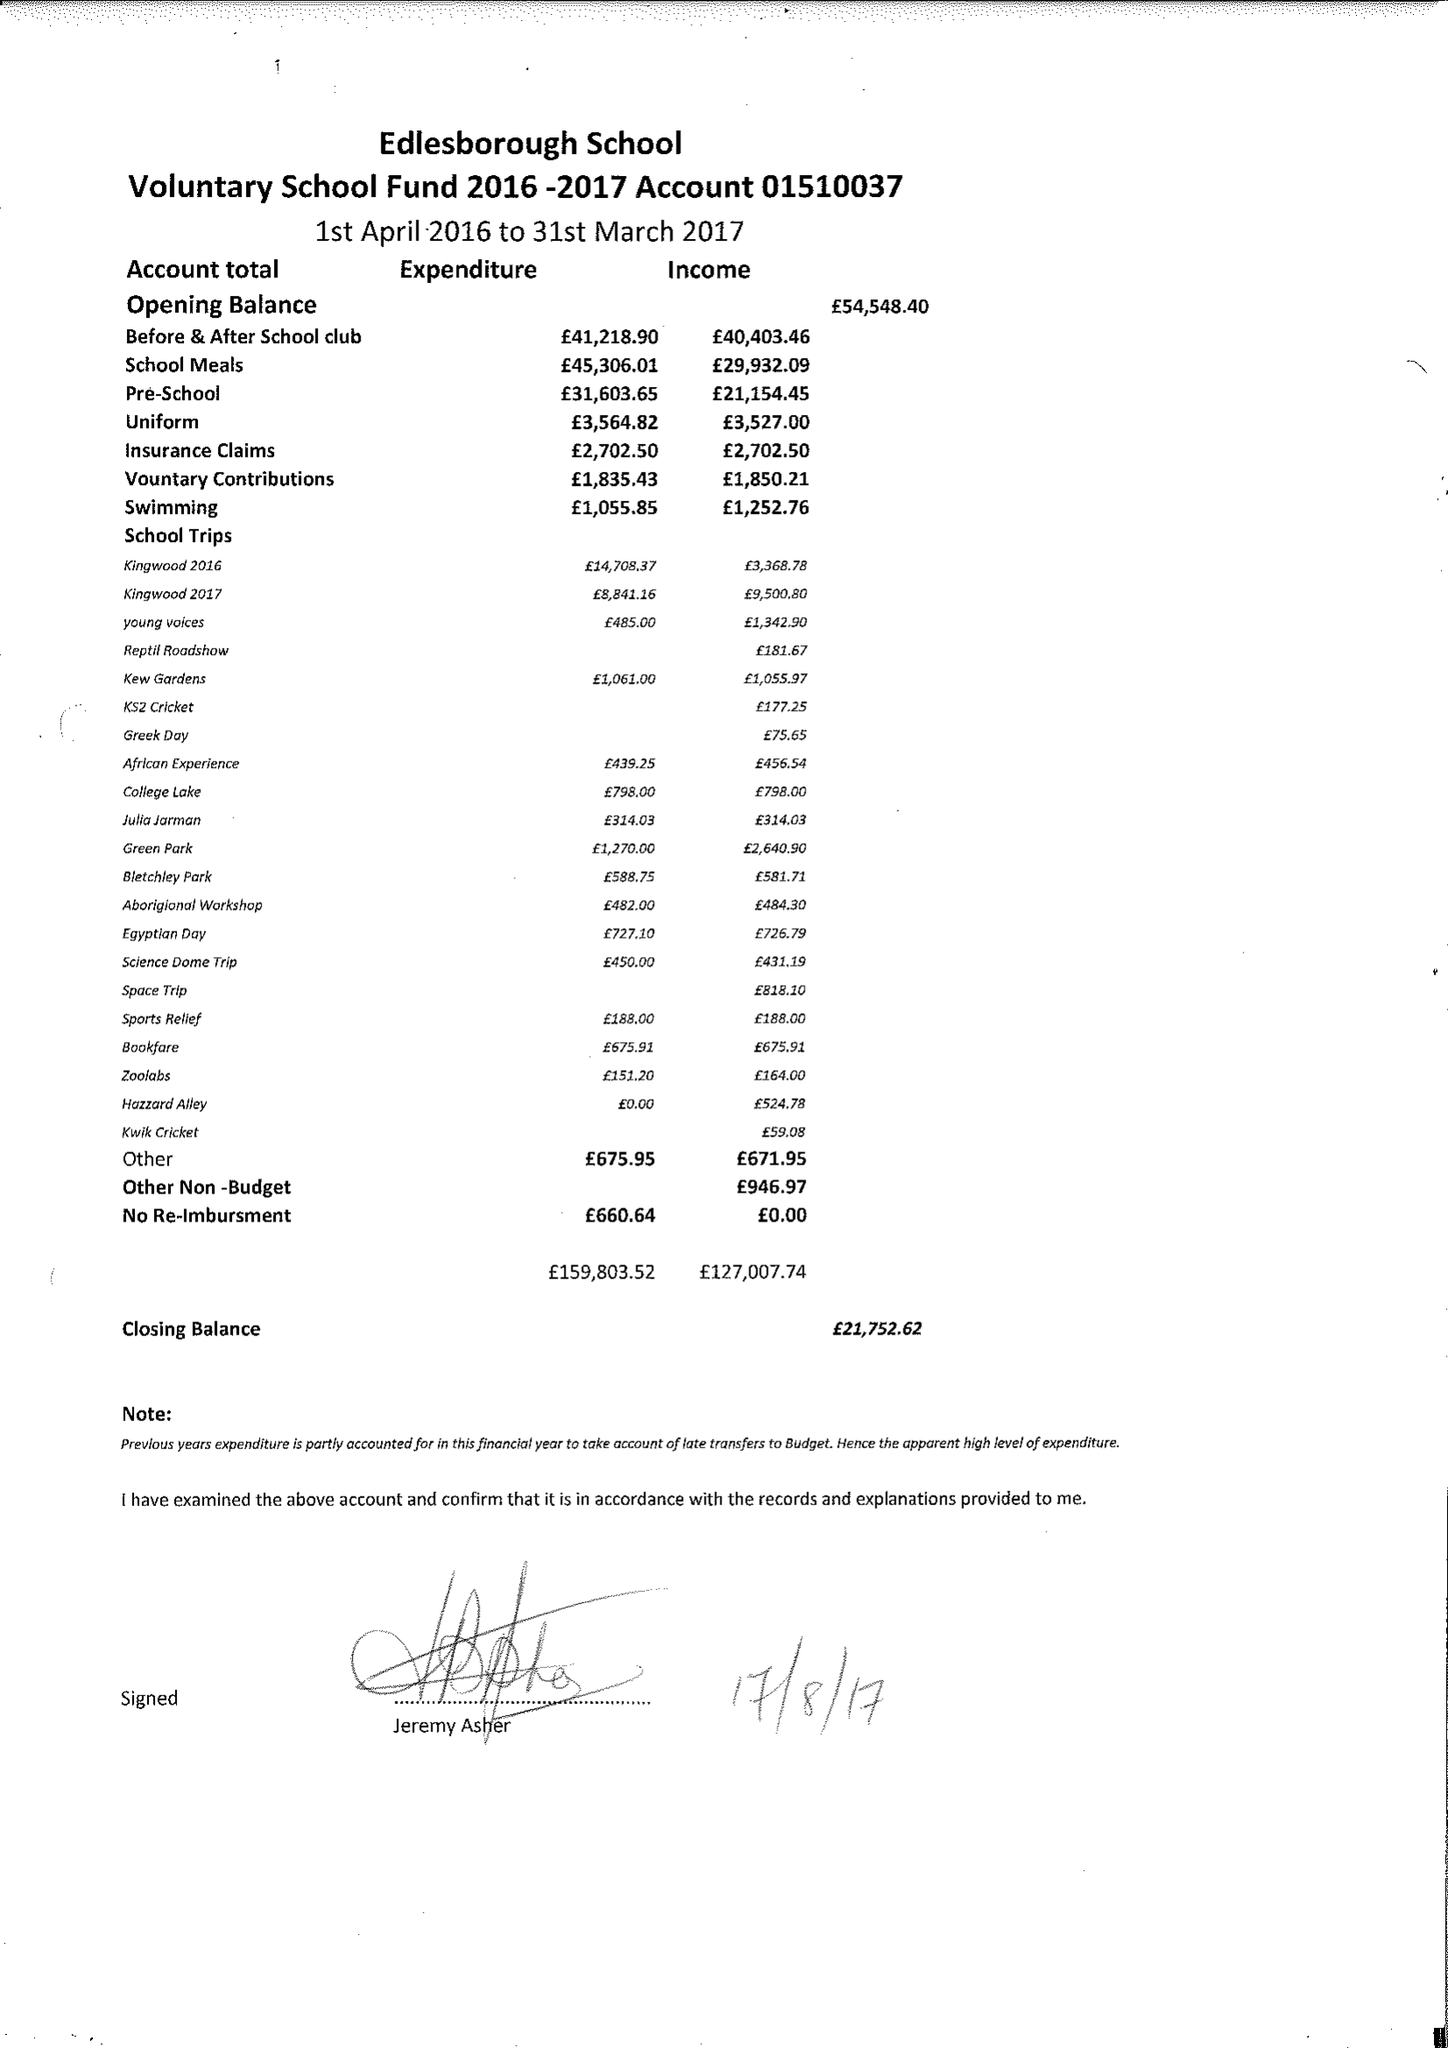What is the value for the address__street_line?
Answer the question using a single word or phrase. HIGH STREET 